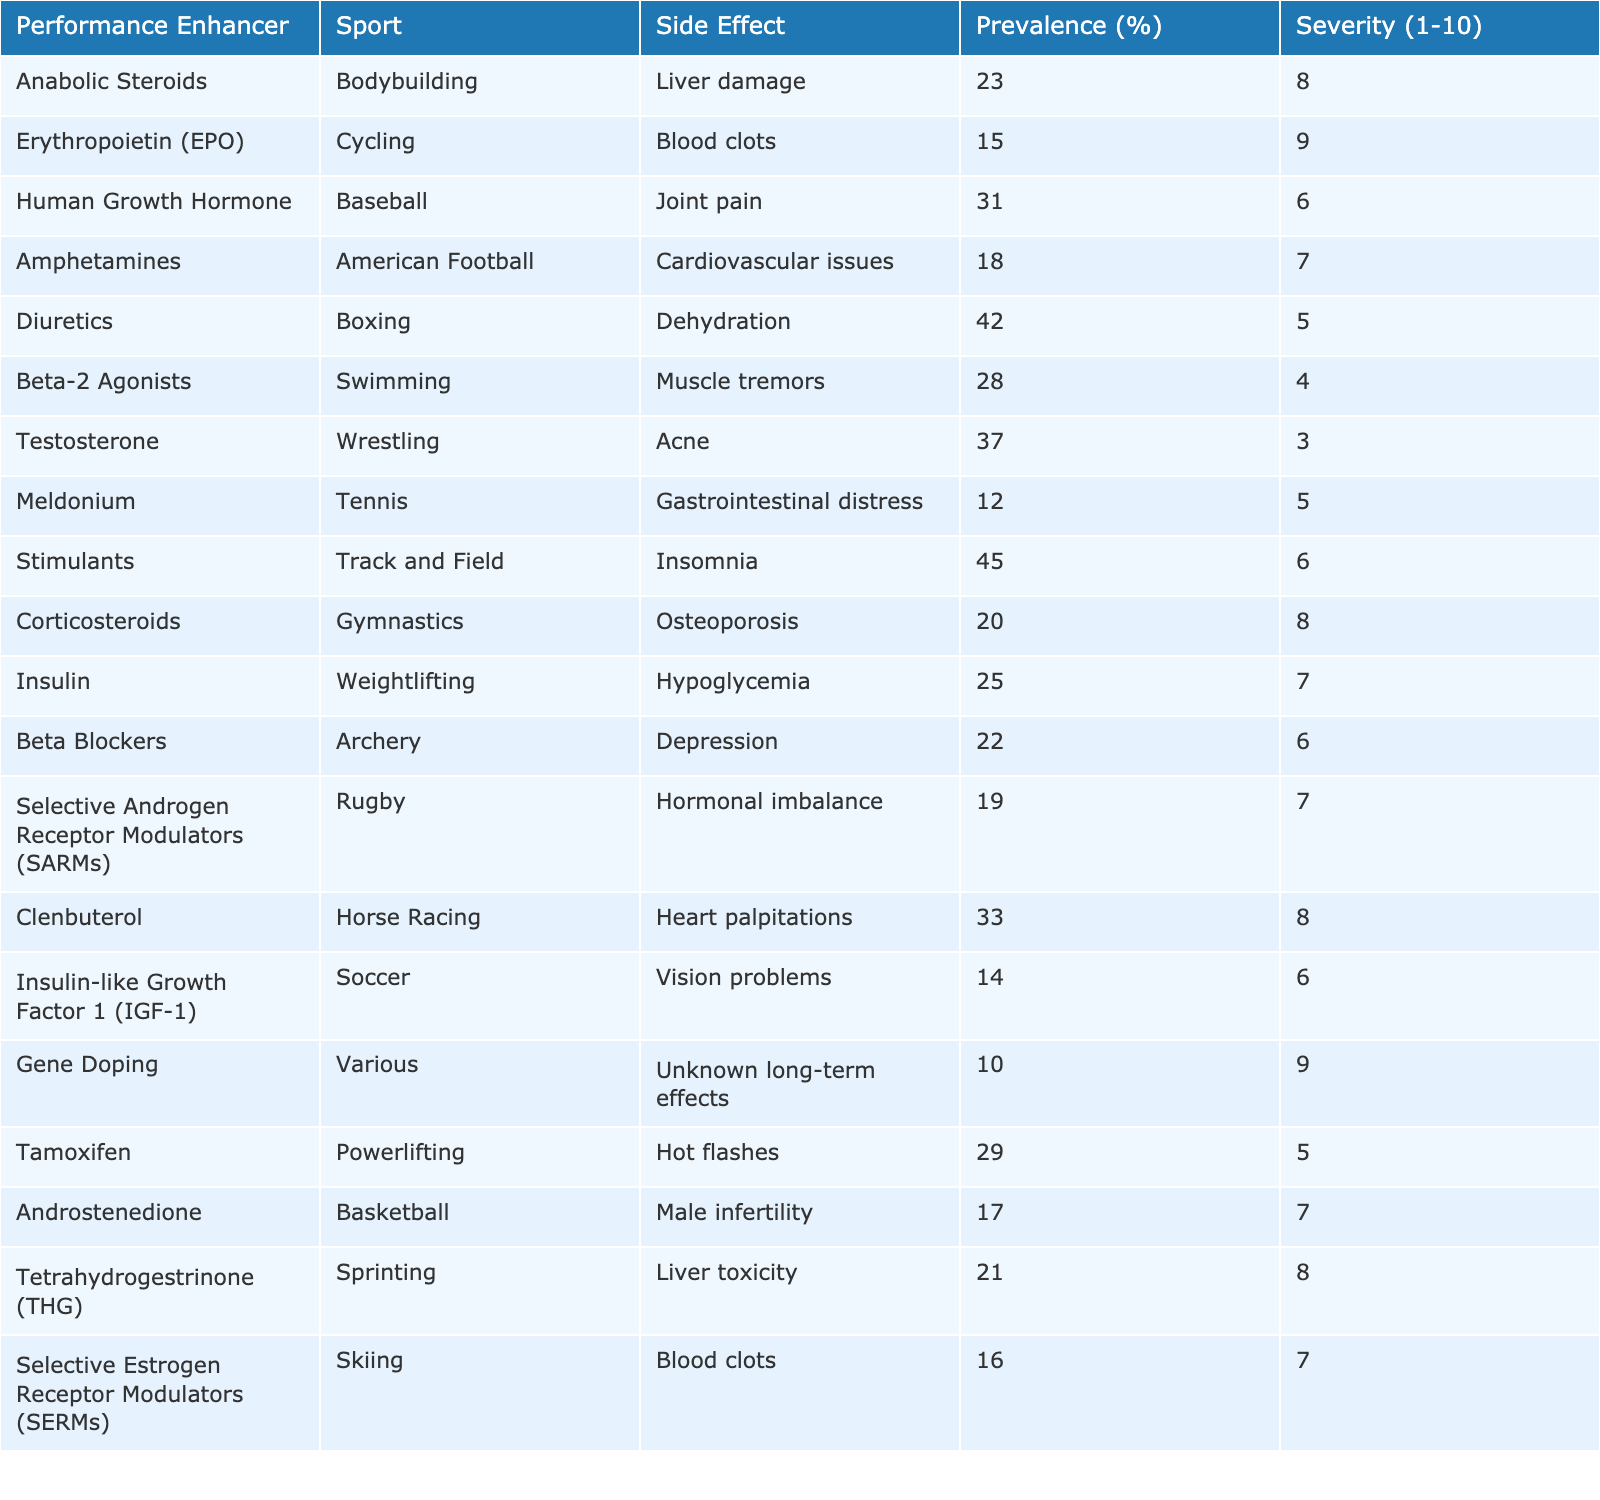What is the most common side effect reported for diuretics? The table shows that dehydration is the reported side effect for diuretics, with a prevalence of 42%.
Answer: Dehydration Which performance enhancer has the highest severity rating? Among the side effects listed, blood clots (Erythropoietin - EPO) has the highest severity rating of 9.
Answer: Blood clots (EPO) What is the average severity rating of the side effects listed in the table? To calculate the average, add all severity ratings: (8 + 9 + 6 + 7 + 5 + 4 + 3 + 5 + 6 + 8 + 7 + 6 + 7 + 8 + 6 + 5 + 7 + 8) = 101. Divide by the number of performance enhancers (16): 101/16 = 6.31 (rounded to two decimal places).
Answer: 6.31 Are there any reported side effects for gene doping? The table indicates that the side effect for gene doping is listed as "unknown long-term effects," implying it does have a reported side effect but not a specified one.
Answer: Yes Which sport has the side effect of cardiovascular issues, and what is its prevalence? According to the table, American Football has cardiovascular issues as a side effect, with a prevalence of 18%.
Answer: American Football, 18% What is the difference in prevalence between lung problems from stimulants and joint pain from HGH? The prevalence of insomnia from stimulants is 45%, and joint pain from HGH is 31%. The difference is 45 - 31 = 14%.
Answer: 14% Which performance enhancer has a side effect related to female hormonal changes? The enhancer tamoxifen is associated with hot flashes, which relate to hormonal changes experienced by females.
Answer: Tamoxifen Identify the two performance enhancers with the lowest prevalence of side effects. From the table, meldonium (12%) and gene doping (10%) have the lowest prevalences of reported side effects.
Answer: Meldonium, Gene Doping What is the significance of the severity rating for corticosteroids in gymnastics? The severity rating of corticosteroids in gymnastics is 8, indicating a high level of concern regarding its side effects, particularly osteoporosis.
Answer: High severity (8) Are there any performance enhancers associated with muscle tremors? The table specifies that beta-2 agonists in swimming are linked to muscle tremors.
Answer: Yes, beta-2 agonists 